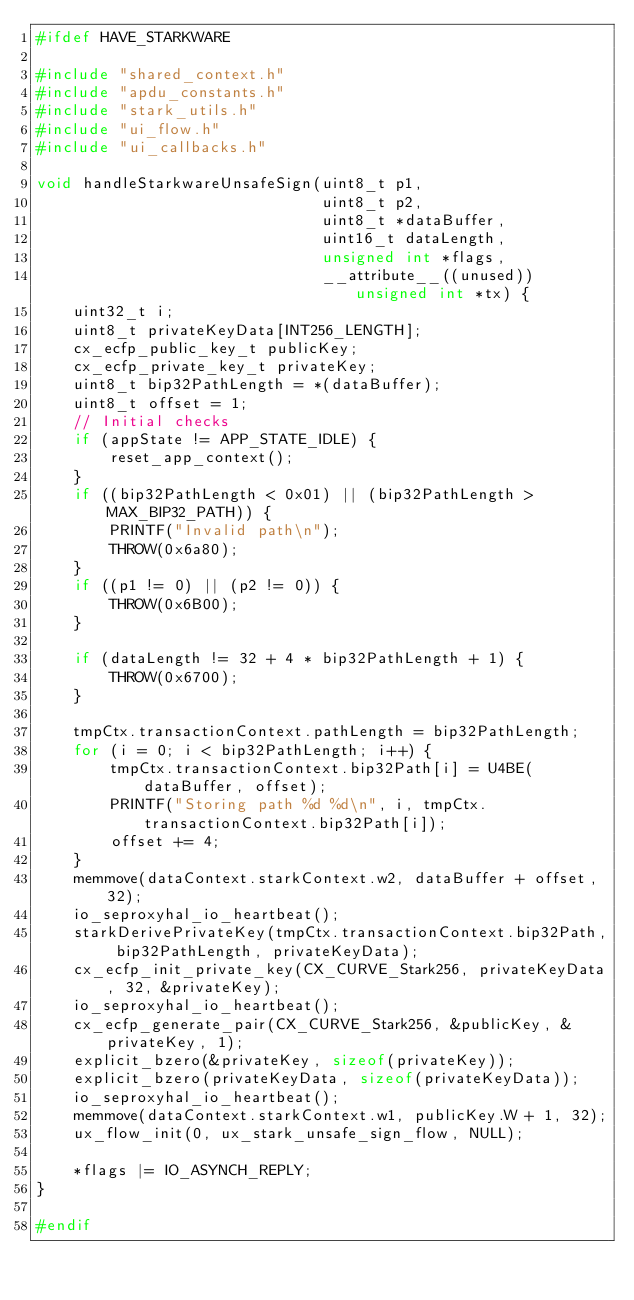<code> <loc_0><loc_0><loc_500><loc_500><_C_>#ifdef HAVE_STARKWARE

#include "shared_context.h"
#include "apdu_constants.h"
#include "stark_utils.h"
#include "ui_flow.h"
#include "ui_callbacks.h"

void handleStarkwareUnsafeSign(uint8_t p1,
                               uint8_t p2,
                               uint8_t *dataBuffer,
                               uint16_t dataLength,
                               unsigned int *flags,
                               __attribute__((unused)) unsigned int *tx) {
    uint32_t i;
    uint8_t privateKeyData[INT256_LENGTH];
    cx_ecfp_public_key_t publicKey;
    cx_ecfp_private_key_t privateKey;
    uint8_t bip32PathLength = *(dataBuffer);
    uint8_t offset = 1;
    // Initial checks
    if (appState != APP_STATE_IDLE) {
        reset_app_context();
    }
    if ((bip32PathLength < 0x01) || (bip32PathLength > MAX_BIP32_PATH)) {
        PRINTF("Invalid path\n");
        THROW(0x6a80);
    }
    if ((p1 != 0) || (p2 != 0)) {
        THROW(0x6B00);
    }

    if (dataLength != 32 + 4 * bip32PathLength + 1) {
        THROW(0x6700);
    }

    tmpCtx.transactionContext.pathLength = bip32PathLength;
    for (i = 0; i < bip32PathLength; i++) {
        tmpCtx.transactionContext.bip32Path[i] = U4BE(dataBuffer, offset);
        PRINTF("Storing path %d %d\n", i, tmpCtx.transactionContext.bip32Path[i]);
        offset += 4;
    }
    memmove(dataContext.starkContext.w2, dataBuffer + offset, 32);
    io_seproxyhal_io_heartbeat();
    starkDerivePrivateKey(tmpCtx.transactionContext.bip32Path, bip32PathLength, privateKeyData);
    cx_ecfp_init_private_key(CX_CURVE_Stark256, privateKeyData, 32, &privateKey);
    io_seproxyhal_io_heartbeat();
    cx_ecfp_generate_pair(CX_CURVE_Stark256, &publicKey, &privateKey, 1);
    explicit_bzero(&privateKey, sizeof(privateKey));
    explicit_bzero(privateKeyData, sizeof(privateKeyData));
    io_seproxyhal_io_heartbeat();
    memmove(dataContext.starkContext.w1, publicKey.W + 1, 32);
    ux_flow_init(0, ux_stark_unsafe_sign_flow, NULL);

    *flags |= IO_ASYNCH_REPLY;
}

#endif
</code> 